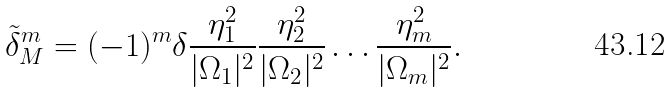Convert formula to latex. <formula><loc_0><loc_0><loc_500><loc_500>\tilde { \delta } ^ { m } _ { M } = ( - 1 ) ^ { m } \delta \frac { \eta _ { 1 } ^ { 2 } } { | \Omega _ { 1 } | ^ { 2 } } \frac { \eta _ { 2 } ^ { 2 } } { | \Omega _ { 2 } | ^ { 2 } } \dots \frac { \eta _ { m } ^ { 2 } } { | \Omega _ { m } | ^ { 2 } } .</formula> 